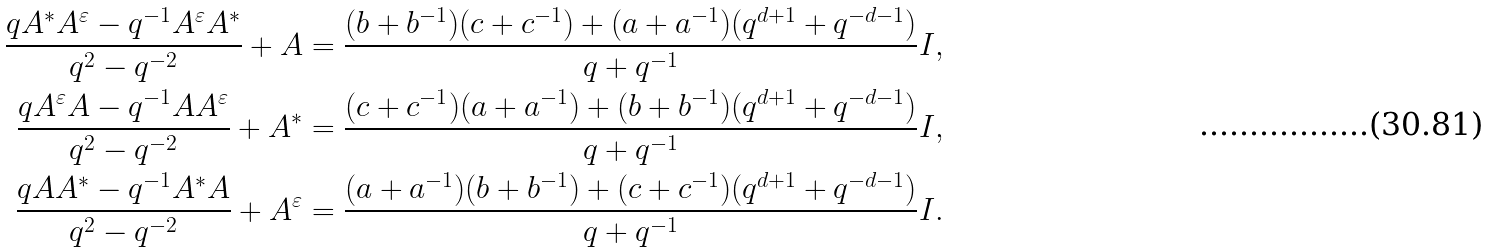Convert formula to latex. <formula><loc_0><loc_0><loc_500><loc_500>\frac { q A ^ { * } A ^ { \varepsilon } - q ^ { - 1 } A ^ { \varepsilon } A ^ { * } } { q ^ { 2 } - q ^ { - 2 } } + A & = \frac { ( b + b ^ { - 1 } ) ( c + c ^ { - 1 } ) + ( a + a ^ { - 1 } ) ( q ^ { d + 1 } + q ^ { - d - 1 } ) } { q + q ^ { - 1 } } I , \\ \frac { q A ^ { \varepsilon } A - q ^ { - 1 } A A ^ { \varepsilon } } { q ^ { 2 } - q ^ { - 2 } } + A ^ { * } & = \frac { ( c + c ^ { - 1 } ) ( a + a ^ { - 1 } ) + ( b + b ^ { - 1 } ) ( q ^ { d + 1 } + q ^ { - d - 1 } ) } { q + q ^ { - 1 } } I , \\ \frac { q A A ^ { * } - q ^ { - 1 } A ^ { * } A } { q ^ { 2 } - q ^ { - 2 } } + A ^ { \varepsilon } & = \frac { ( a + a ^ { - 1 } ) ( b + b ^ { - 1 } ) + ( c + c ^ { - 1 } ) ( q ^ { d + 1 } + q ^ { - d - 1 } ) } { q + q ^ { - 1 } } I .</formula> 